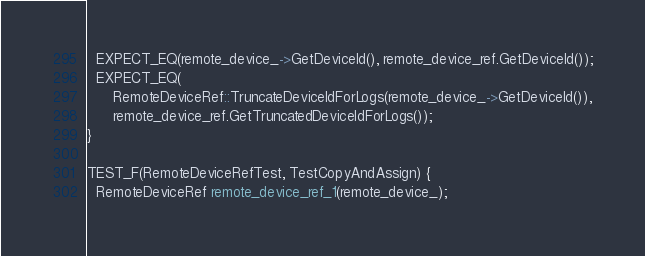<code> <loc_0><loc_0><loc_500><loc_500><_C++_>  EXPECT_EQ(remote_device_->GetDeviceId(), remote_device_ref.GetDeviceId());
  EXPECT_EQ(
      RemoteDeviceRef::TruncateDeviceIdForLogs(remote_device_->GetDeviceId()),
      remote_device_ref.GetTruncatedDeviceIdForLogs());
}

TEST_F(RemoteDeviceRefTest, TestCopyAndAssign) {
  RemoteDeviceRef remote_device_ref_1(remote_device_);
</code> 